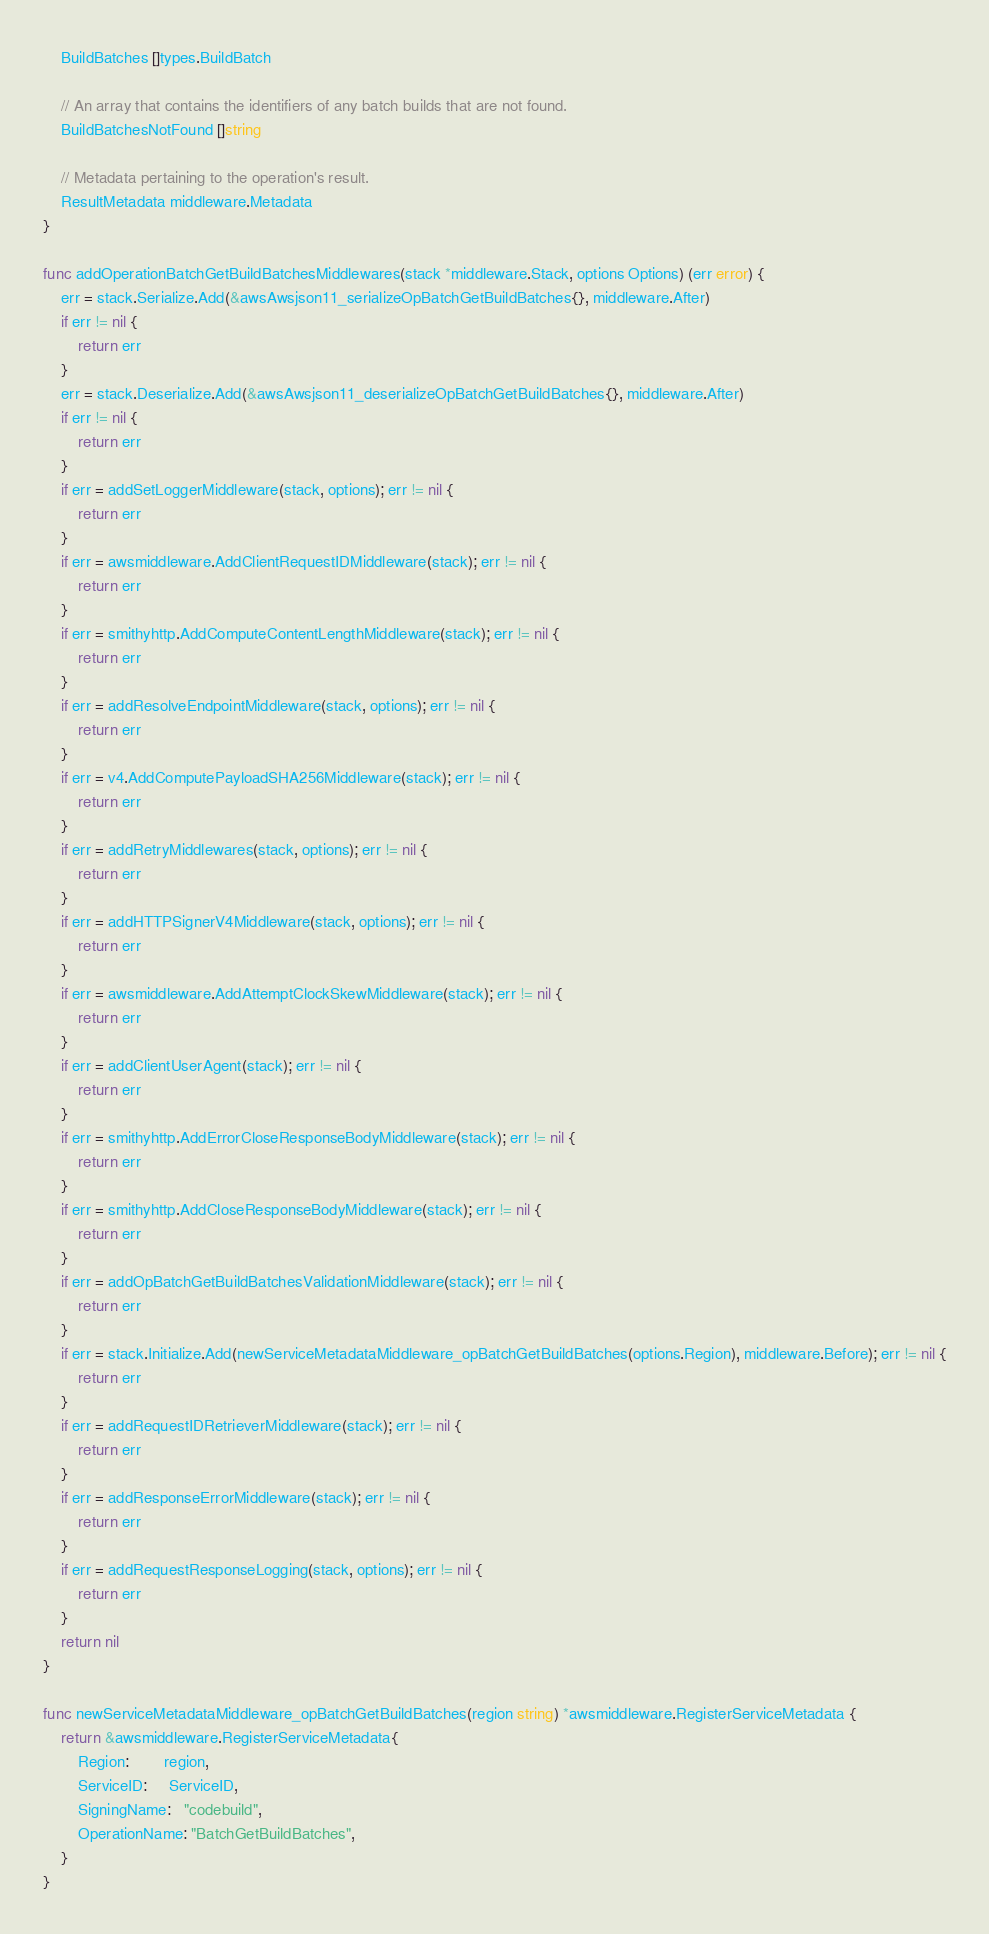<code> <loc_0><loc_0><loc_500><loc_500><_Go_>	BuildBatches []types.BuildBatch

	// An array that contains the identifiers of any batch builds that are not found.
	BuildBatchesNotFound []string

	// Metadata pertaining to the operation's result.
	ResultMetadata middleware.Metadata
}

func addOperationBatchGetBuildBatchesMiddlewares(stack *middleware.Stack, options Options) (err error) {
	err = stack.Serialize.Add(&awsAwsjson11_serializeOpBatchGetBuildBatches{}, middleware.After)
	if err != nil {
		return err
	}
	err = stack.Deserialize.Add(&awsAwsjson11_deserializeOpBatchGetBuildBatches{}, middleware.After)
	if err != nil {
		return err
	}
	if err = addSetLoggerMiddleware(stack, options); err != nil {
		return err
	}
	if err = awsmiddleware.AddClientRequestIDMiddleware(stack); err != nil {
		return err
	}
	if err = smithyhttp.AddComputeContentLengthMiddleware(stack); err != nil {
		return err
	}
	if err = addResolveEndpointMiddleware(stack, options); err != nil {
		return err
	}
	if err = v4.AddComputePayloadSHA256Middleware(stack); err != nil {
		return err
	}
	if err = addRetryMiddlewares(stack, options); err != nil {
		return err
	}
	if err = addHTTPSignerV4Middleware(stack, options); err != nil {
		return err
	}
	if err = awsmiddleware.AddAttemptClockSkewMiddleware(stack); err != nil {
		return err
	}
	if err = addClientUserAgent(stack); err != nil {
		return err
	}
	if err = smithyhttp.AddErrorCloseResponseBodyMiddleware(stack); err != nil {
		return err
	}
	if err = smithyhttp.AddCloseResponseBodyMiddleware(stack); err != nil {
		return err
	}
	if err = addOpBatchGetBuildBatchesValidationMiddleware(stack); err != nil {
		return err
	}
	if err = stack.Initialize.Add(newServiceMetadataMiddleware_opBatchGetBuildBatches(options.Region), middleware.Before); err != nil {
		return err
	}
	if err = addRequestIDRetrieverMiddleware(stack); err != nil {
		return err
	}
	if err = addResponseErrorMiddleware(stack); err != nil {
		return err
	}
	if err = addRequestResponseLogging(stack, options); err != nil {
		return err
	}
	return nil
}

func newServiceMetadataMiddleware_opBatchGetBuildBatches(region string) *awsmiddleware.RegisterServiceMetadata {
	return &awsmiddleware.RegisterServiceMetadata{
		Region:        region,
		ServiceID:     ServiceID,
		SigningName:   "codebuild",
		OperationName: "BatchGetBuildBatches",
	}
}
</code> 